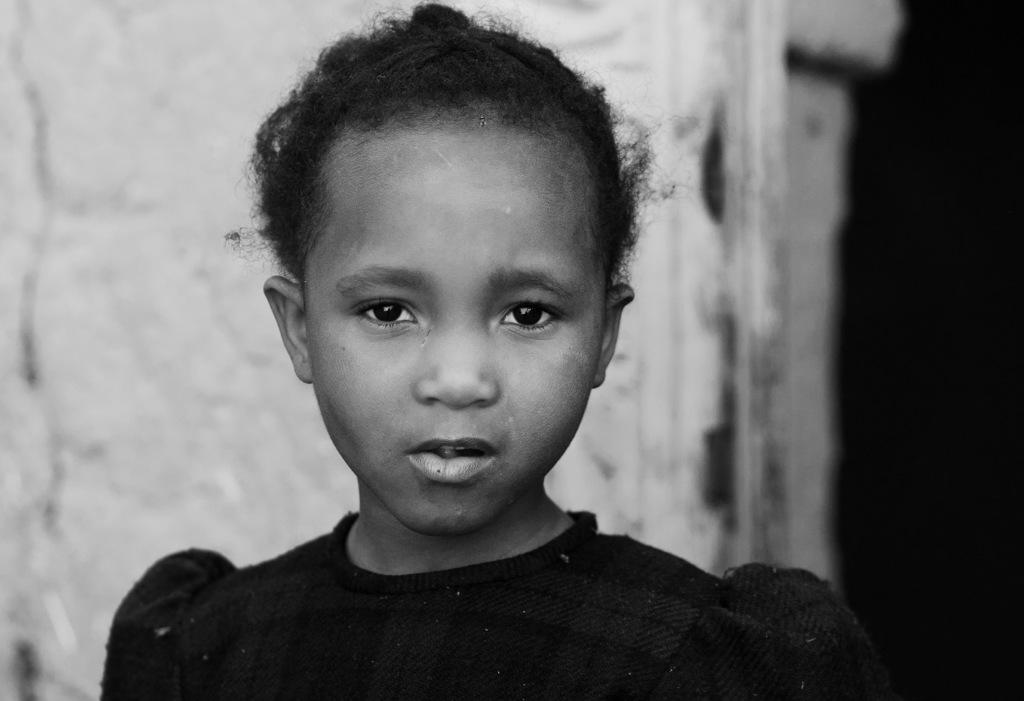What is the main subject of the image? The main subject of the image is a kid. What can be observed about the kid's attire? The kid is wearing clothes. How would you describe the color scheme of the image? The image is black and white. Can you describe the background of the image? The background of the image is blurred. How many cacti are visible in the image? There are no cacti present in the image. Are the kid's sisters visible in the image? The provided facts do not mention any sisters, so we cannot determine if they are present in the image. 